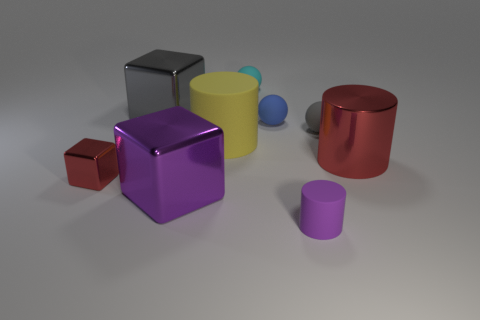Subtract all purple blocks. How many blocks are left? 2 Subtract all gray rubber spheres. How many spheres are left? 2 Subtract 1 balls. How many balls are left? 2 Subtract all cylinders. How many objects are left? 6 Subtract all purple spheres. How many red cubes are left? 1 Add 5 tiny purple matte cylinders. How many tiny purple matte cylinders exist? 6 Subtract 0 brown cylinders. How many objects are left? 9 Subtract all purple cylinders. Subtract all brown spheres. How many cylinders are left? 2 Subtract all tiny metal blocks. Subtract all small blue matte spheres. How many objects are left? 7 Add 8 small gray matte spheres. How many small gray matte spheres are left? 9 